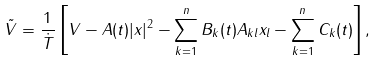Convert formula to latex. <formula><loc_0><loc_0><loc_500><loc_500>\tilde { V } = \frac { 1 } { \dot { T } } \left [ V - A ( t ) | x | ^ { 2 } - \sum _ { k = 1 } ^ { n } B _ { k } ( t ) A _ { k l } x _ { l } - \sum _ { k = 1 } ^ { n } C _ { k } ( t ) \right ] ,</formula> 